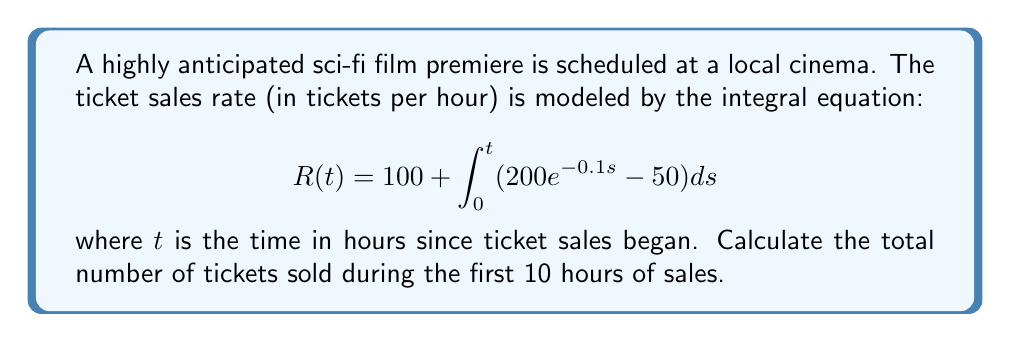Show me your answer to this math problem. To solve this problem, we need to follow these steps:

1) First, we need to solve the integral equation for $R(t)$:

   $$R(t) = 100 + \int_0^t (200e^{-0.1s} - 50)ds$$

2) Let's solve the integral:

   $$\int_0^t (200e^{-0.1s} - 50)ds = [-2000e^{-0.1s} - 50s]_0^t$$
   
   $$= (-2000e^{-0.1t} - 50t) - (-2000 - 0)$$
   
   $$= 2000 - 2000e^{-0.1t} - 50t$$

3) Now we can write $R(t)$ as:

   $$R(t) = 100 + 2000 - 2000e^{-0.1t} - 50t$$
   
   $$R(t) = 2100 - 2000e^{-0.1t} - 50t$$

4) The total number of tickets sold is the integral of $R(t)$ from 0 to 10:

   $$\text{Total tickets} = \int_0^{10} R(t)dt$$

5) Let's solve this integral:

   $$\int_0^{10} (2100 - 2000e^{-0.1t} - 50t)dt$$
   
   $$= [2100t + 20000e^{-0.1t} - 25t^2]_0^{10}$$
   
   $$= (21000 + 20000e^{-1} - 2500) - (0 + 20000 - 0)$$
   
   $$= 21000 + 20000e^{-1} - 2500 - 20000$$
   
   $$= 18500 + 20000e^{-1}$$

6) Calculate the final value:

   $$18500 + 20000 * 0.3679 \approx 25858$$

Therefore, approximately 25,858 tickets were sold during the first 10 hours.
Answer: 25,858 tickets 